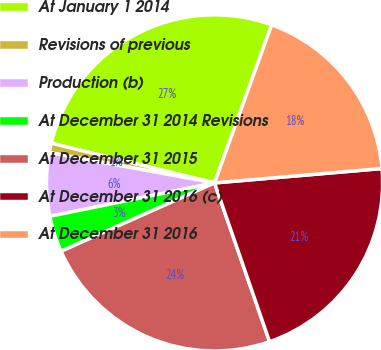<chart> <loc_0><loc_0><loc_500><loc_500><pie_chart><fcel>At January 1 2014<fcel>Revisions of previous<fcel>Production (b)<fcel>At December 31 2014 Revisions<fcel>At December 31 2015<fcel>At December 31 2016 (c)<fcel>At December 31 2016<nl><fcel>26.72%<fcel>0.91%<fcel>6.07%<fcel>3.49%<fcel>23.64%<fcel>21.06%<fcel>18.12%<nl></chart> 